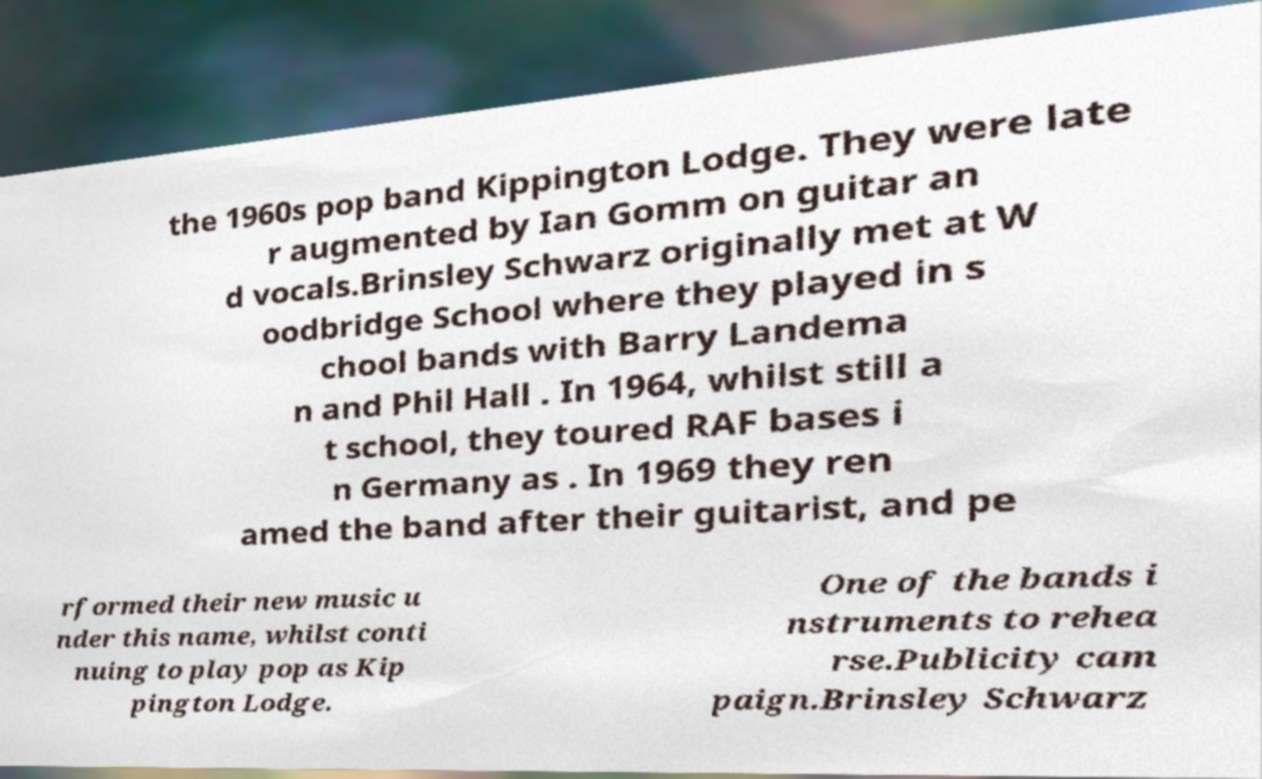Can you read and provide the text displayed in the image?This photo seems to have some interesting text. Can you extract and type it out for me? the 1960s pop band Kippington Lodge. They were late r augmented by Ian Gomm on guitar an d vocals.Brinsley Schwarz originally met at W oodbridge School where they played in s chool bands with Barry Landema n and Phil Hall . In 1964, whilst still a t school, they toured RAF bases i n Germany as . In 1969 they ren amed the band after their guitarist, and pe rformed their new music u nder this name, whilst conti nuing to play pop as Kip pington Lodge. One of the bands i nstruments to rehea rse.Publicity cam paign.Brinsley Schwarz 